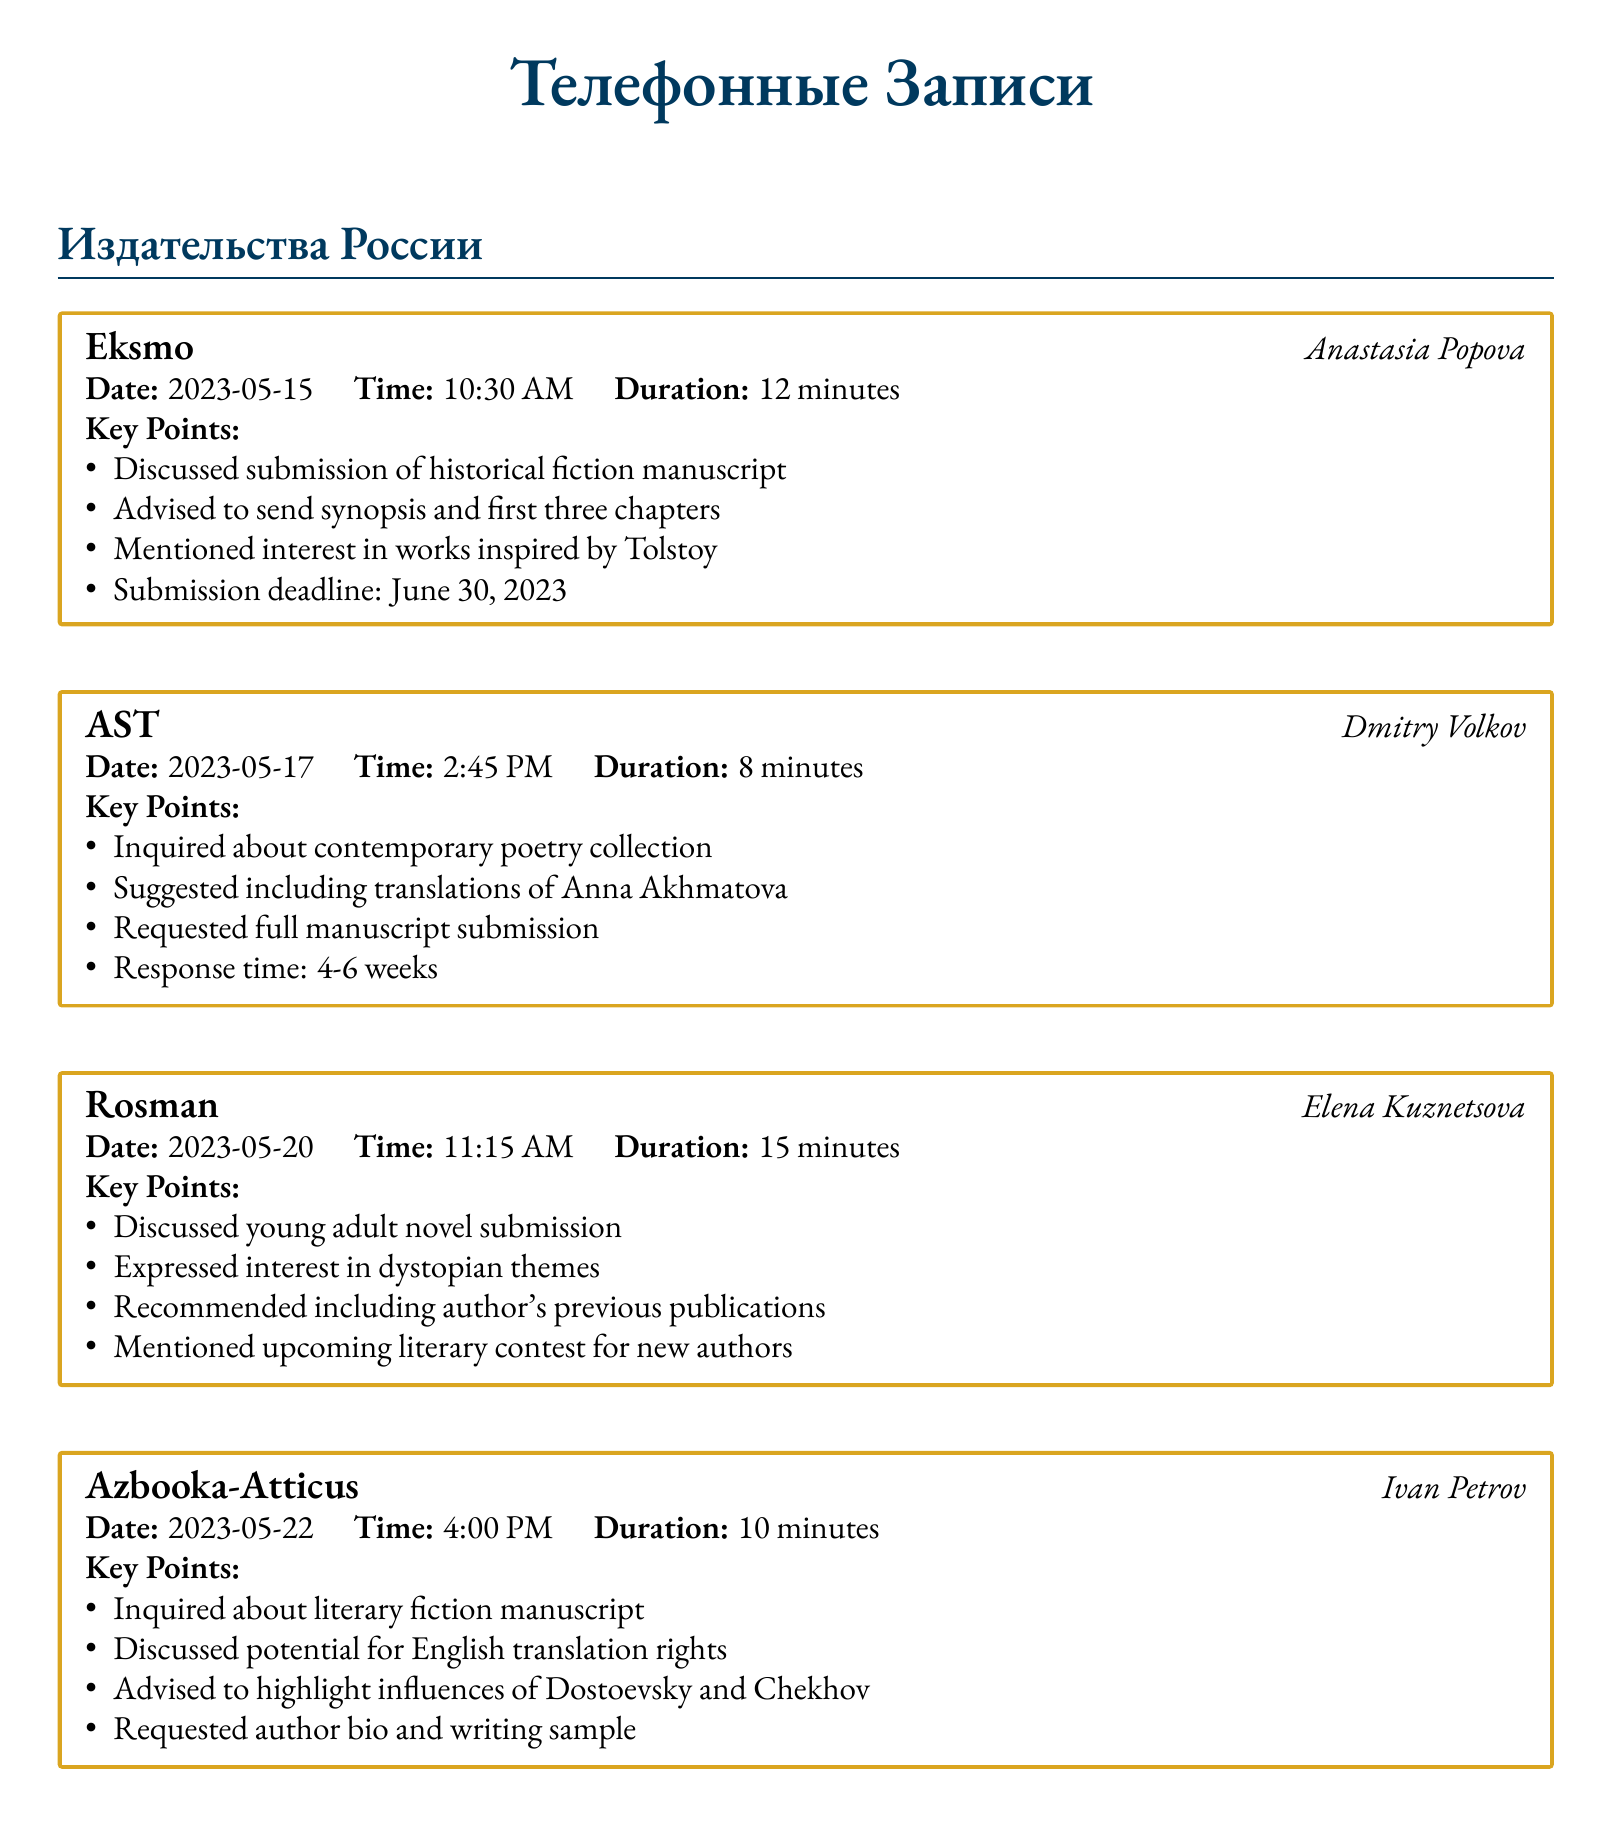What is the name of the first publishing house contacted? The first publishing house mentioned in the document is Eksmo.
Answer: Eksmo What was the date of the interview with Dmitry Volkov? The interview with Dmitry Volkov took place on May 17, 2023.
Answer: 2023-05-17 How long did the phone call with Elena Kuznetsova last? The duration of the phone call with Elena Kuznetsova was 15 minutes.
Answer: 15 minutes What specific themes did Rosman express interest in? Rosman expressed interest in dystopian themes during the call.
Answer: Dystopian themes What type of manuscript did Ivan Petrov inquire about? Ivan Petrov inquired about a literary fiction manuscript.
Answer: Literary fiction How many weeks is the response time expected from AST? The response time expected from AST is 4-6 weeks.
Answer: 4-6 weeks What is the submission deadline mentioned by Eksmo? The submission deadline mentioned by Eksmo is June 30, 2023.
Answer: June 30, 2023 Which authors should be highlighted according to Azbooka-Atticus? Azbooka-Atticus advised highlighting influences of Dostoevsky and Chekhov.
Answer: Dostoevsky and Chekhov Which genre was discussed in the call with Anastasia Popova? The genre discussed with Anastasia Popova was historical fiction.
Answer: Historical fiction 